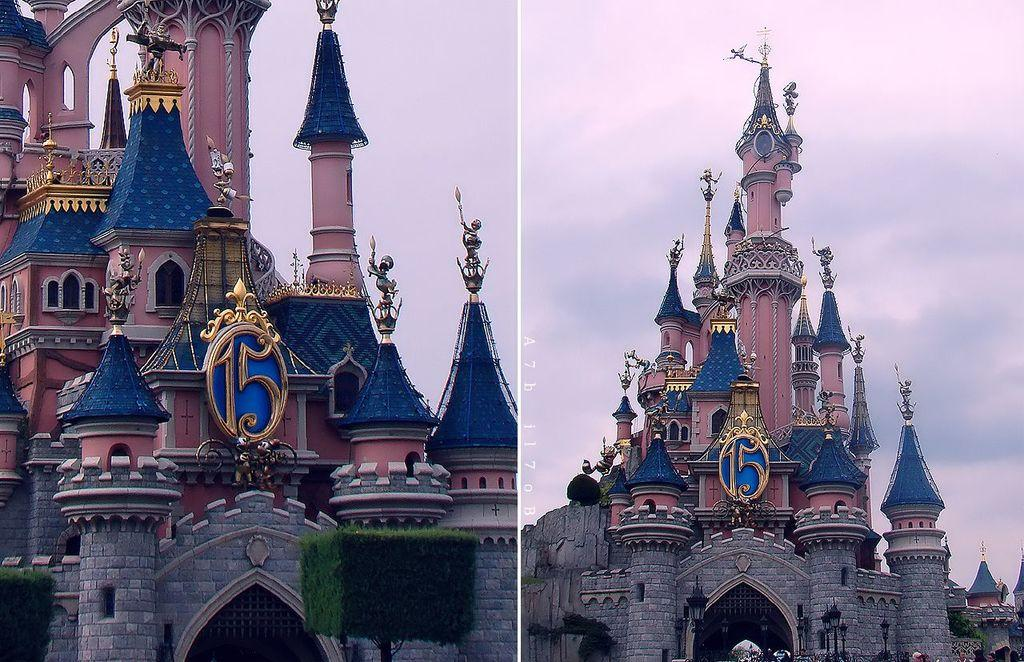What type of image is shown in the picture? The image is a photo collage. What subject matter is depicted in the collage? The collage appears to depict a fort. What is visible at the top of the image? The sky is visible at the top of the image. What is the condition of the sky in the image? The sky is cloudy in the image. Is there a swing visible in the image? No, there is no swing present in the image. What type of payment is required to enter the fort depicted in the image? There is no information about payment or entrance fees in the image. 